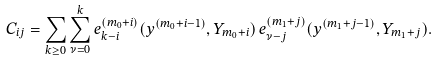<formula> <loc_0><loc_0><loc_500><loc_500>C _ { i j } = \sum _ { k \geq 0 } \sum _ { \nu = 0 } ^ { k } e ^ { ( m _ { 0 } + i ) } _ { k - i } ( y ^ { ( m _ { 0 } + i - 1 ) } , Y _ { m _ { 0 } + i } ) \, e ^ { ( m _ { 1 } + j ) } _ { \nu - j } ( y ^ { ( m _ { 1 } + j - 1 ) } , Y _ { m _ { 1 } + j } ) .</formula> 